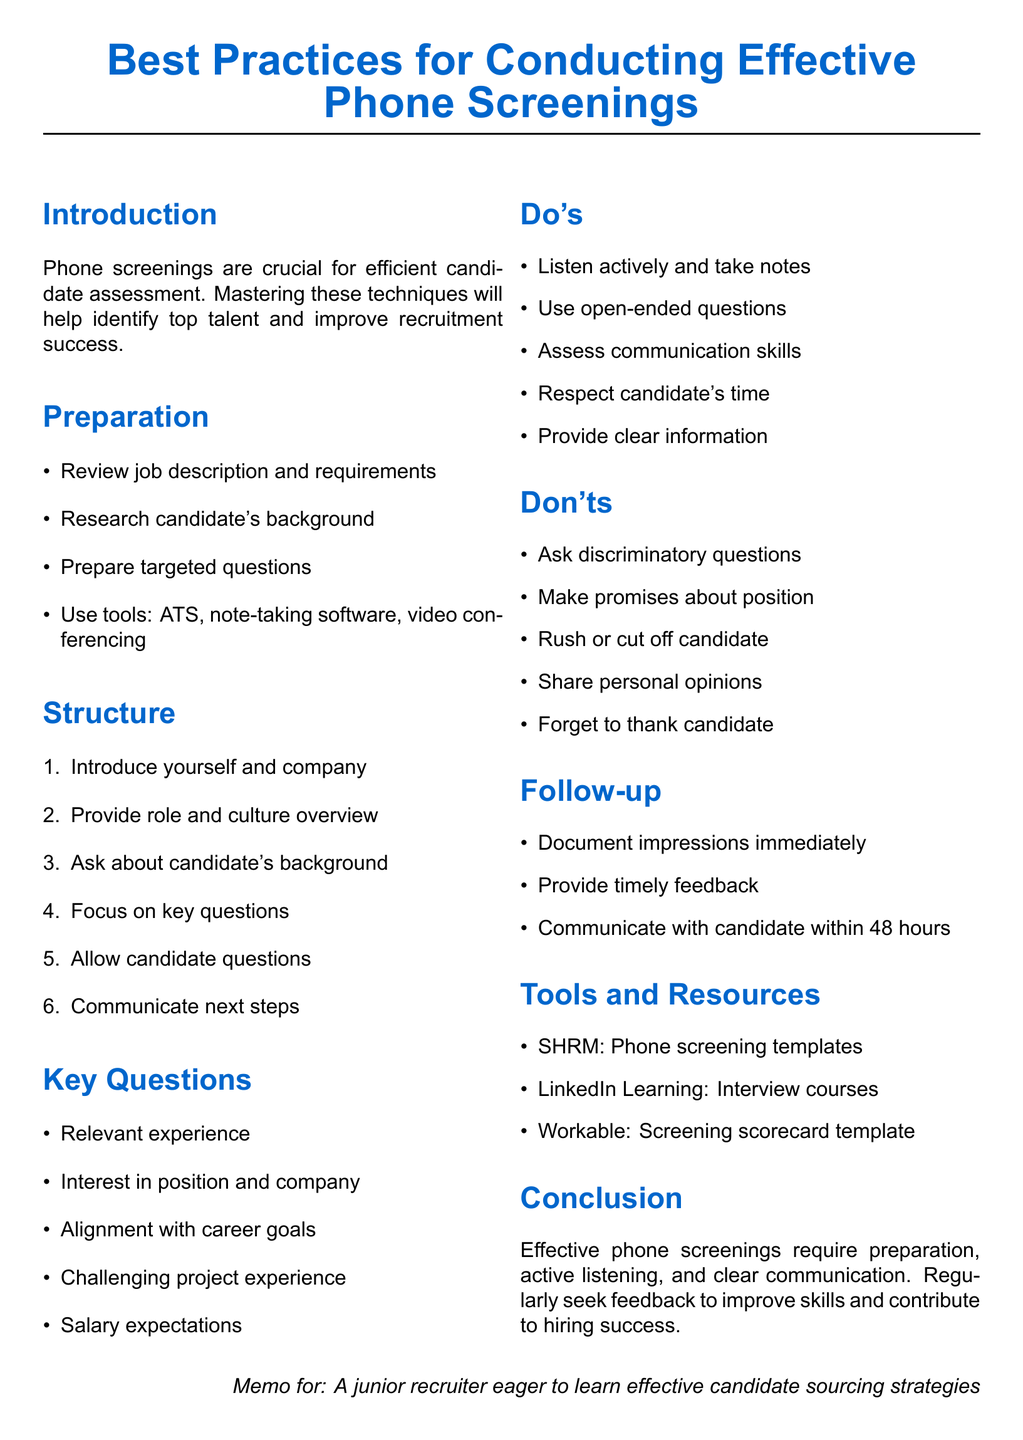What is the key takeaway from the conclusion? The key takeaway summarizes the main point made in the conclusion about effective phone screenings.
Answer: Effective phone screenings require preparation, active listening, and clear communication What should you do after the call? This refers to the actions recommended in the follow-up section of the document.
Answer: Document your impressions and key takeaways immediately after the call Name one tool mentioned for note-taking. This asks for specific examples of tools listed in the preparation section.
Answer: Evernote What type of questions should you use during the screening? This refers to the recommended question types according to the do's section in the document.
Answer: Open-ended questions How many key questions are listed in the document? This is a numerical query about the number of key questions provided.
Answer: Five What should be included in the overview given to candidates? The question relates to the structure of the phone screening as mentioned in the document.
Answer: A high-level overview of the role and company culture Which organization provides phone screening templates? This asks for a specific resource mentioned in the tools and resources section.
Answer: SHRM What should you avoid doing during a call? This refers to the foundational principle set out in the don’ts section of the document.
Answer: Asking discriminatory or illegal questions 